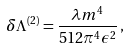Convert formula to latex. <formula><loc_0><loc_0><loc_500><loc_500>\delta \Lambda ^ { ( 2 ) } = \frac { \lambda m ^ { 4 } } { 5 1 2 \pi ^ { 4 } \epsilon ^ { 2 } } \, ,</formula> 